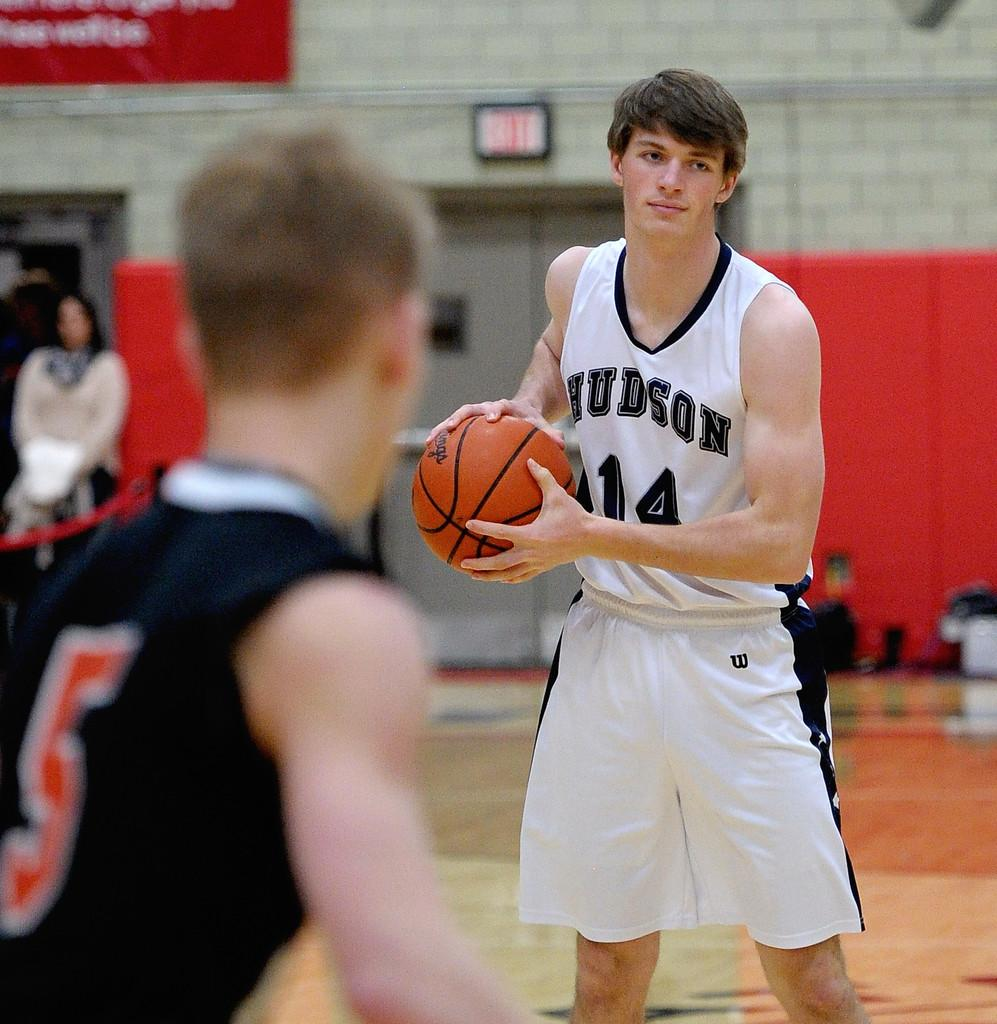<image>
Relay a brief, clear account of the picture shown. A guy in a uniform with the number 14 on it has the basketball. 